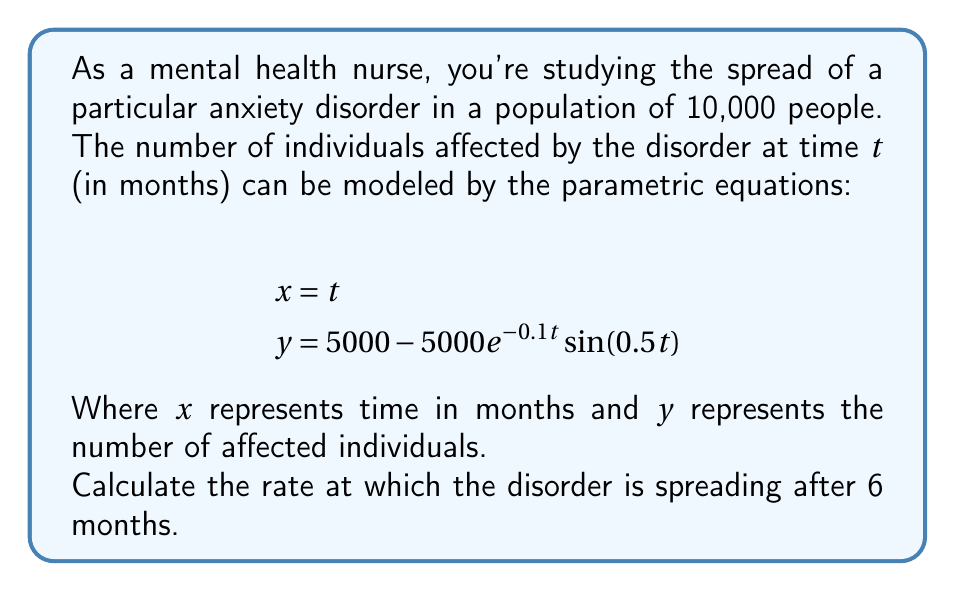Can you answer this question? To solve this problem, we need to follow these steps:

1) The rate of spread is given by the derivative $\frac{dy}{dx}$. In parametric equations, this is calculated as $\frac{dy}{dx} = \frac{dy/dt}{dx/dt}$.

2) First, let's find $\frac{dx}{dt}$:
   $$\frac{dx}{dt} = 1$$ (since $x = t$)

3) Next, let's find $\frac{dy}{dt}$:
   $$\frac{dy}{dt} = 500e^{-0.1t}\sin(0.5t) - 2500e^{-0.1t}\cos(0.5t)$$

4) Now we can calculate $\frac{dy}{dx}$:
   $$\frac{dy}{dx} = \frac{dy/dt}{dx/dt} = 500e^{-0.1t}\sin(0.5t) - 2500e^{-0.1t}\cos(0.5t)$$

5) To find the rate after 6 months, we substitute $t = 6$ into this equation:
   $$\frac{dy}{dx}\bigg|_{t=6} = 500e^{-0.6}\sin(3) - 2500e^{-0.6}\cos(3)$$

6) Calculate this value:
   $$\frac{dy}{dx}\bigg|_{t=6} \approx 500 \cdot 0.5488 \cdot 0.1411 - 2500 \cdot 0.5488 \cdot (-0.9900)$$
   $$\approx 38.7 + 1359.8 = 1398.5$$

Therefore, after 6 months, the disorder is spreading at a rate of approximately 1399 new cases per month.
Answer: 1399 new cases per month 